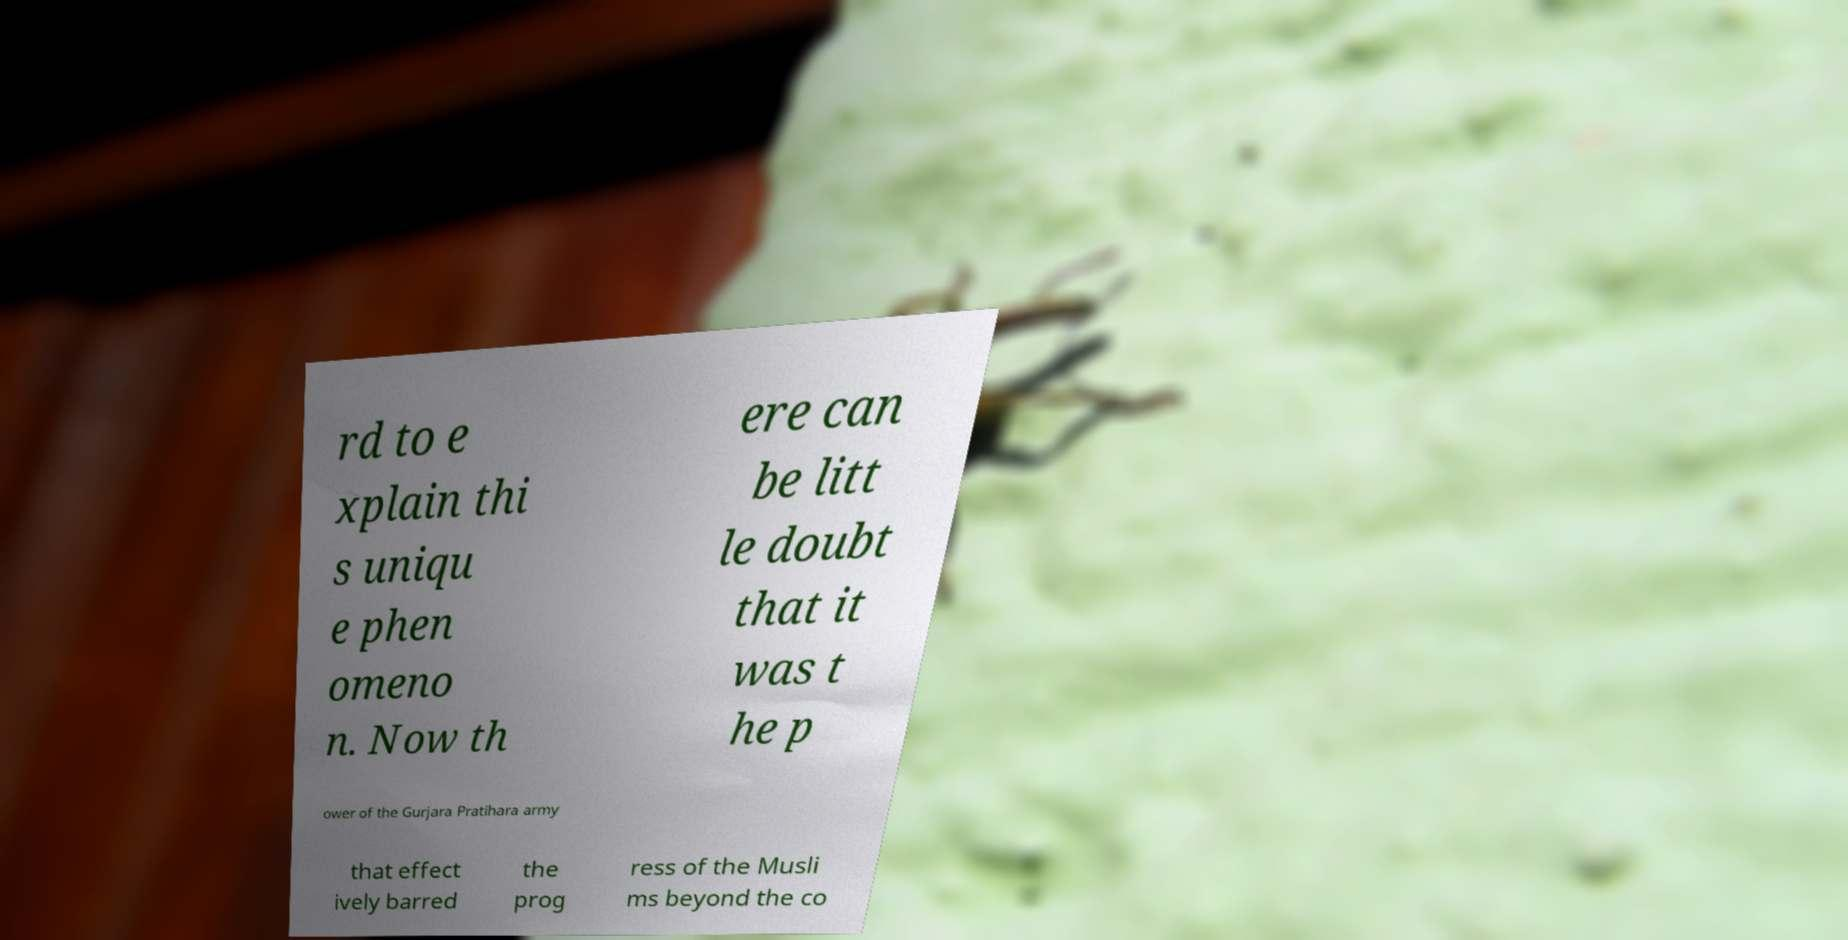For documentation purposes, I need the text within this image transcribed. Could you provide that? rd to e xplain thi s uniqu e phen omeno n. Now th ere can be litt le doubt that it was t he p ower of the Gurjara Pratihara army that effect ively barred the prog ress of the Musli ms beyond the co 